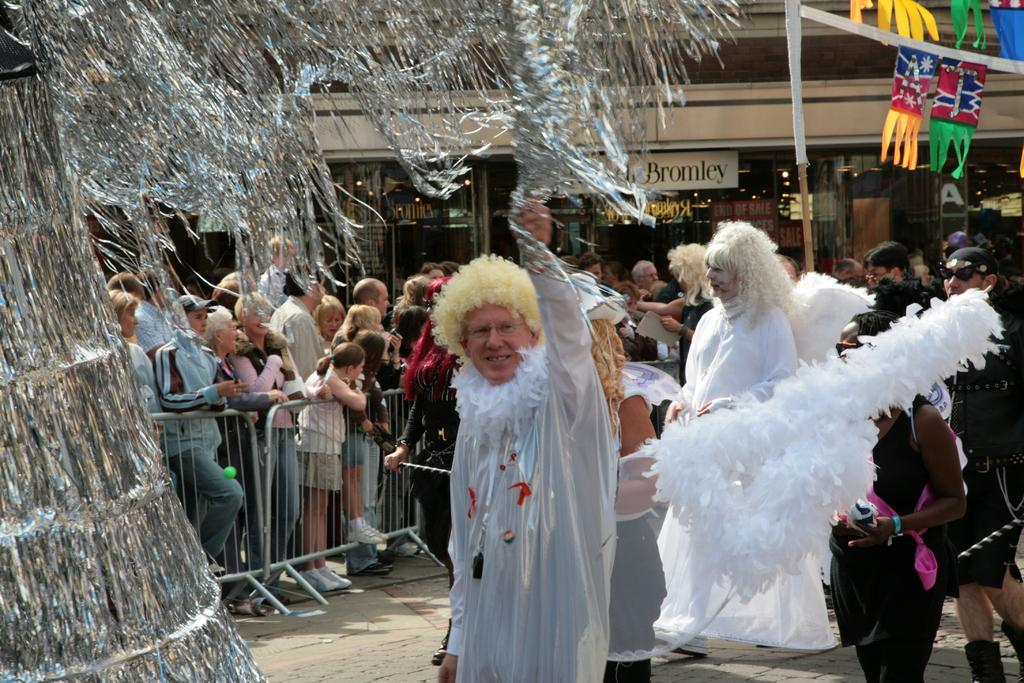Where are the persons located in the image? The persons are standing in the right corner of the image. What are the persons wearing in the image? The persons are wearing fancy dress. What can be seen in the background of the image? There is a fence, persons, a building, and other objects in the background of the image. What songs are the giraffes singing in the image? There are no giraffes present in the image, so there is no singing or any related activity. 